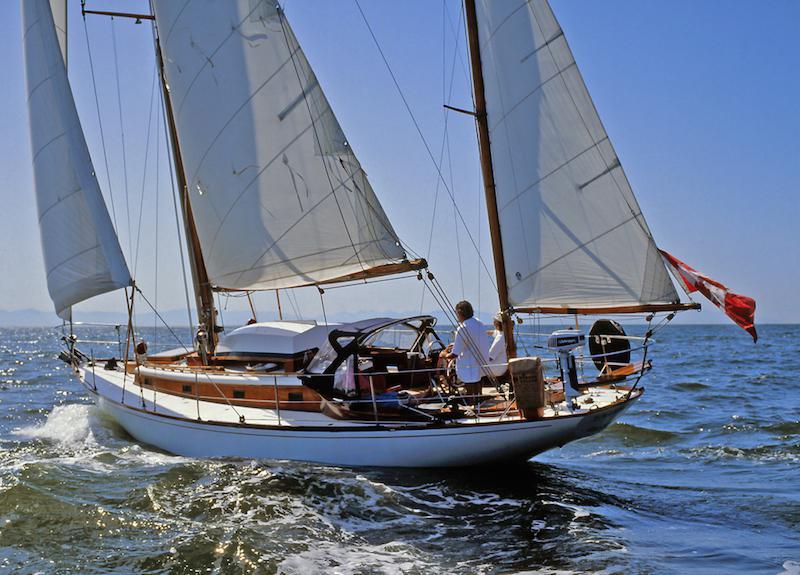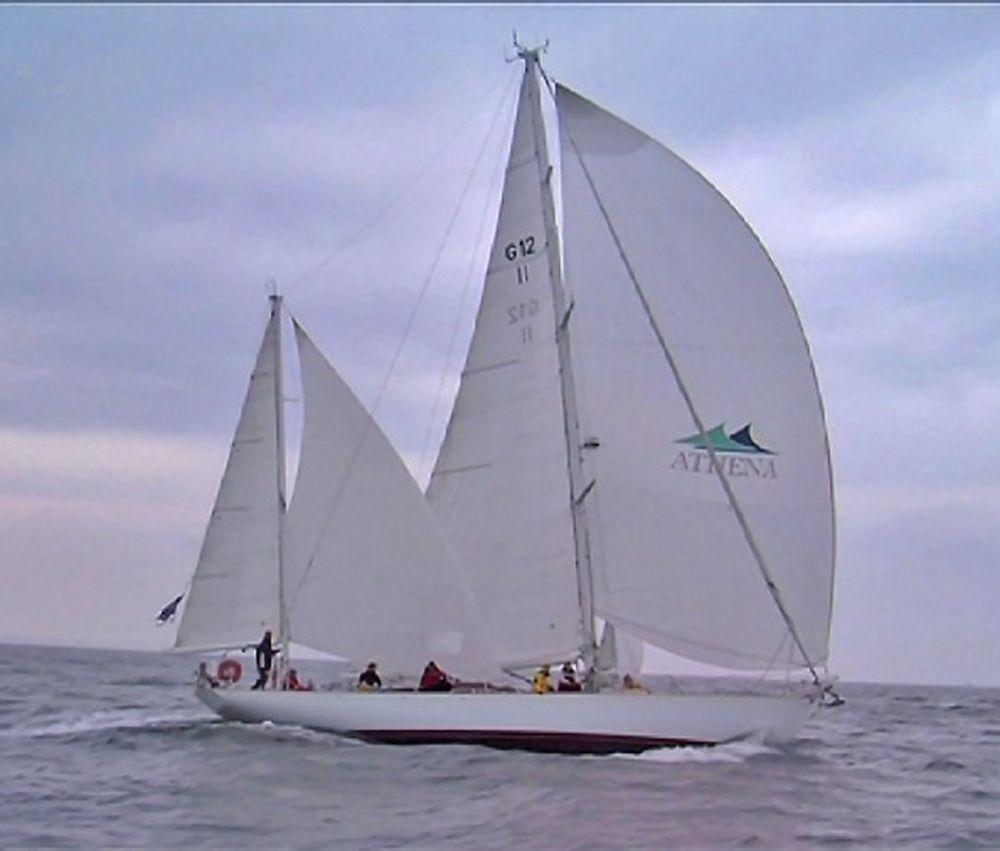The first image is the image on the left, the second image is the image on the right. Considering the images on both sides, is "There are exactly three inflated sails in the image on the right." valid? Answer yes or no. No. The first image is the image on the left, the second image is the image on the right. For the images shown, is this caption "The boat in the photo on the right is flying a flag off its rearmost line." true? Answer yes or no. Yes. 